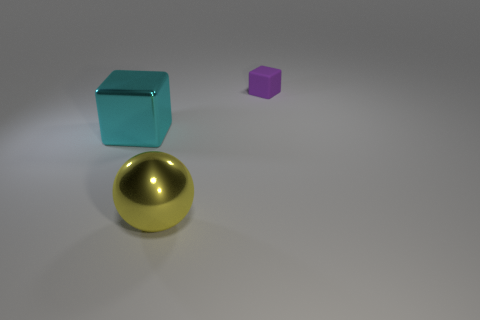Is there any other thing that has the same size as the purple rubber block?
Provide a short and direct response. No. Are there any other things that are the same shape as the yellow metal object?
Ensure brevity in your answer.  No. Is the large yellow ball made of the same material as the cube on the right side of the large cyan metal thing?
Your response must be concise. No. What number of blocks are both on the left side of the small purple cube and right of the shiny cube?
Your answer should be very brief. 0. What is the shape of the object that is the same size as the yellow shiny sphere?
Your response must be concise. Cube. There is a large metallic object that is in front of the cube to the left of the big yellow ball; are there any tiny purple objects that are in front of it?
Make the answer very short. No. There is a small rubber thing; is its color the same as the cube that is in front of the small purple matte thing?
Offer a terse response. No. What number of large blocks have the same color as the sphere?
Offer a terse response. 0. There is a cube that is to the right of the big metallic thing behind the large yellow shiny thing; what size is it?
Your answer should be very brief. Small. What number of things are either blocks to the left of the yellow thing or big cyan blocks?
Offer a terse response. 1. 